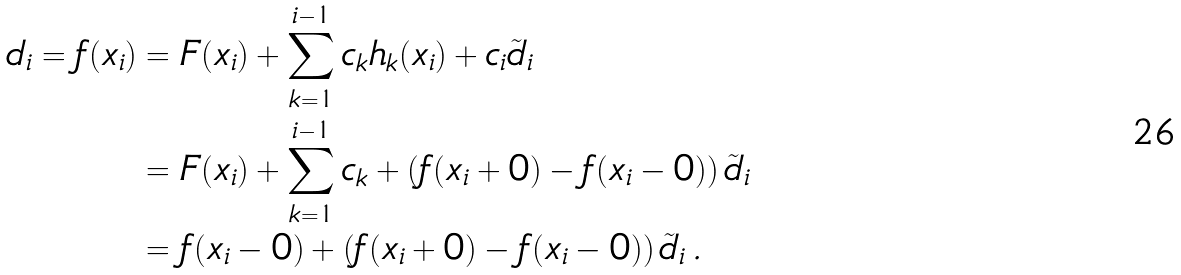<formula> <loc_0><loc_0><loc_500><loc_500>d _ { i } = f ( x _ { i } ) & = F ( x _ { i } ) + \sum ^ { i - 1 } _ { k = 1 } c _ { k } h _ { k } ( x _ { i } ) + c _ { i } \tilde { d } _ { i } \\ & = F ( x _ { i } ) + \sum ^ { i - 1 } _ { k = 1 } c _ { k } + \left ( f ( x _ { i } + 0 ) - f ( x _ { i } - 0 ) \right ) \tilde { d } _ { i } \\ & = f ( x _ { i } - 0 ) + \left ( f ( x _ { i } + 0 ) - f ( x _ { i } - 0 ) \right ) \tilde { d } _ { i } \, .</formula> 